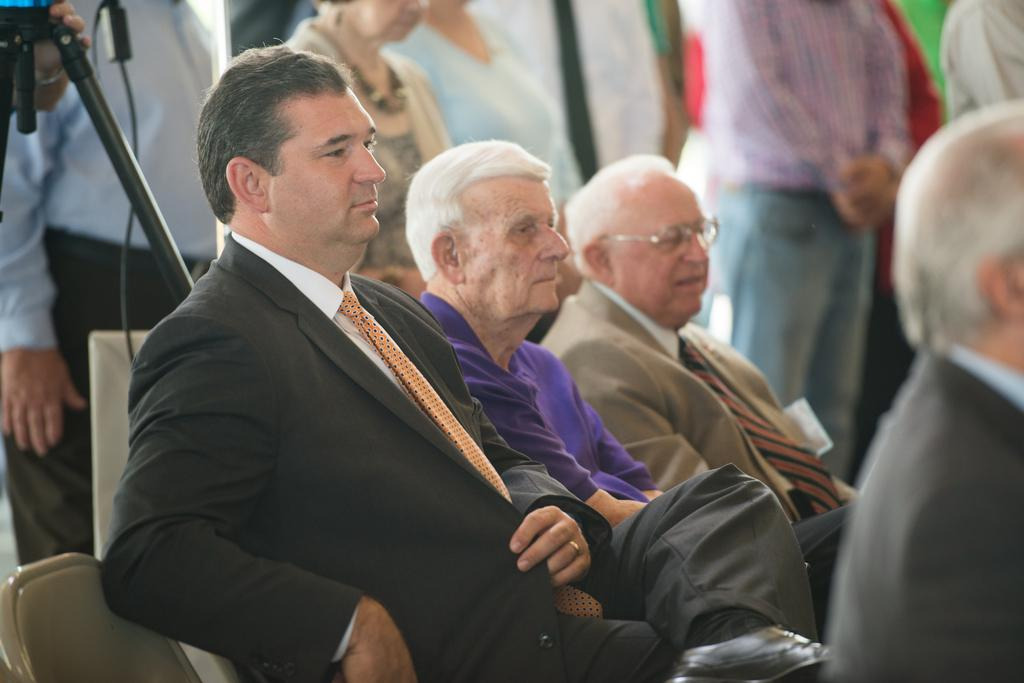What can be seen in the image related to people? There are persons wearing clothes in the image. What objects are located in the top left of the image? There is a tripod and a cable in the top left of the image. What type of tub can be seen in the image? There is no tub present in the image. How many drops of blood are visible in the image? There are no drops of blood visible in the image. 